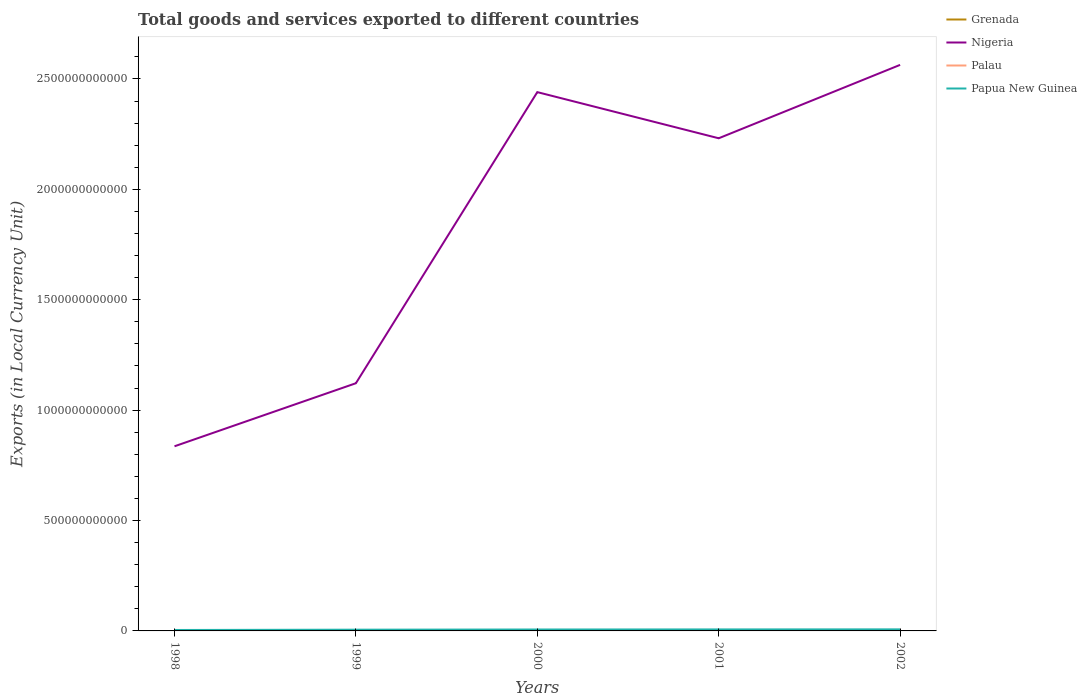Across all years, what is the maximum Amount of goods and services exports in Nigeria?
Provide a short and direct response. 8.36e+11. What is the total Amount of goods and services exports in Nigeria in the graph?
Offer a terse response. -1.40e+12. What is the difference between the highest and the second highest Amount of goods and services exports in Nigeria?
Offer a terse response. 1.73e+12. What is the difference between the highest and the lowest Amount of goods and services exports in Grenada?
Ensure brevity in your answer.  3. Is the Amount of goods and services exports in Nigeria strictly greater than the Amount of goods and services exports in Grenada over the years?
Keep it short and to the point. No. How many lines are there?
Offer a terse response. 4. How many years are there in the graph?
Your answer should be very brief. 5. What is the difference between two consecutive major ticks on the Y-axis?
Offer a terse response. 5.00e+11. Are the values on the major ticks of Y-axis written in scientific E-notation?
Keep it short and to the point. No. Does the graph contain grids?
Ensure brevity in your answer.  No. Where does the legend appear in the graph?
Offer a terse response. Top right. How many legend labels are there?
Offer a very short reply. 4. What is the title of the graph?
Your answer should be very brief. Total goods and services exported to different countries. Does "China" appear as one of the legend labels in the graph?
Ensure brevity in your answer.  No. What is the label or title of the X-axis?
Your response must be concise. Years. What is the label or title of the Y-axis?
Keep it short and to the point. Exports (in Local Currency Unit). What is the Exports (in Local Currency Unit) in Grenada in 1998?
Ensure brevity in your answer.  4.25e+08. What is the Exports (in Local Currency Unit) in Nigeria in 1998?
Offer a terse response. 8.36e+11. What is the Exports (in Local Currency Unit) of Palau in 1998?
Ensure brevity in your answer.  1.11e+07. What is the Exports (in Local Currency Unit) in Papua New Guinea in 1998?
Ensure brevity in your answer.  4.22e+09. What is the Exports (in Local Currency Unit) in Grenada in 1999?
Provide a short and direct response. 5.89e+08. What is the Exports (in Local Currency Unit) of Nigeria in 1999?
Your answer should be very brief. 1.12e+12. What is the Exports (in Local Currency Unit) of Palau in 1999?
Offer a very short reply. 1.36e+07. What is the Exports (in Local Currency Unit) of Papua New Guinea in 1999?
Provide a short and direct response. 5.57e+09. What is the Exports (in Local Currency Unit) in Grenada in 2000?
Give a very brief answer. 6.36e+08. What is the Exports (in Local Currency Unit) of Nigeria in 2000?
Your response must be concise. 2.44e+12. What is the Exports (in Local Currency Unit) in Palau in 2000?
Give a very brief answer. 6.67e+07. What is the Exports (in Local Currency Unit) in Papua New Guinea in 2000?
Your answer should be compact. 6.44e+09. What is the Exports (in Local Currency Unit) in Grenada in 2001?
Offer a terse response. 5.32e+08. What is the Exports (in Local Currency Unit) of Nigeria in 2001?
Your response must be concise. 2.23e+12. What is the Exports (in Local Currency Unit) of Palau in 2001?
Keep it short and to the point. 6.93e+07. What is the Exports (in Local Currency Unit) of Papua New Guinea in 2001?
Your answer should be compact. 6.79e+09. What is the Exports (in Local Currency Unit) of Grenada in 2002?
Provide a succinct answer. 4.66e+08. What is the Exports (in Local Currency Unit) in Nigeria in 2002?
Provide a succinct answer. 2.56e+12. What is the Exports (in Local Currency Unit) in Palau in 2002?
Make the answer very short. 7.42e+07. What is the Exports (in Local Currency Unit) in Papua New Guinea in 2002?
Give a very brief answer. 7.10e+09. Across all years, what is the maximum Exports (in Local Currency Unit) of Grenada?
Provide a short and direct response. 6.36e+08. Across all years, what is the maximum Exports (in Local Currency Unit) in Nigeria?
Keep it short and to the point. 2.56e+12. Across all years, what is the maximum Exports (in Local Currency Unit) of Palau?
Offer a terse response. 7.42e+07. Across all years, what is the maximum Exports (in Local Currency Unit) of Papua New Guinea?
Your response must be concise. 7.10e+09. Across all years, what is the minimum Exports (in Local Currency Unit) in Grenada?
Your answer should be very brief. 4.25e+08. Across all years, what is the minimum Exports (in Local Currency Unit) of Nigeria?
Offer a very short reply. 8.36e+11. Across all years, what is the minimum Exports (in Local Currency Unit) in Palau?
Your answer should be compact. 1.11e+07. Across all years, what is the minimum Exports (in Local Currency Unit) of Papua New Guinea?
Provide a succinct answer. 4.22e+09. What is the total Exports (in Local Currency Unit) of Grenada in the graph?
Offer a very short reply. 2.65e+09. What is the total Exports (in Local Currency Unit) of Nigeria in the graph?
Offer a terse response. 9.19e+12. What is the total Exports (in Local Currency Unit) of Palau in the graph?
Provide a short and direct response. 2.35e+08. What is the total Exports (in Local Currency Unit) in Papua New Guinea in the graph?
Your answer should be compact. 3.01e+1. What is the difference between the Exports (in Local Currency Unit) in Grenada in 1998 and that in 1999?
Ensure brevity in your answer.  -1.64e+08. What is the difference between the Exports (in Local Currency Unit) in Nigeria in 1998 and that in 1999?
Give a very brief answer. -2.86e+11. What is the difference between the Exports (in Local Currency Unit) of Palau in 1998 and that in 1999?
Give a very brief answer. -2.48e+06. What is the difference between the Exports (in Local Currency Unit) in Papua New Guinea in 1998 and that in 1999?
Keep it short and to the point. -1.36e+09. What is the difference between the Exports (in Local Currency Unit) of Grenada in 1998 and that in 2000?
Your response must be concise. -2.11e+08. What is the difference between the Exports (in Local Currency Unit) in Nigeria in 1998 and that in 2000?
Offer a terse response. -1.60e+12. What is the difference between the Exports (in Local Currency Unit) of Palau in 1998 and that in 2000?
Offer a terse response. -5.56e+07. What is the difference between the Exports (in Local Currency Unit) in Papua New Guinea in 1998 and that in 2000?
Your answer should be compact. -2.23e+09. What is the difference between the Exports (in Local Currency Unit) in Grenada in 1998 and that in 2001?
Your answer should be very brief. -1.07e+08. What is the difference between the Exports (in Local Currency Unit) in Nigeria in 1998 and that in 2001?
Your answer should be compact. -1.40e+12. What is the difference between the Exports (in Local Currency Unit) in Palau in 1998 and that in 2001?
Your response must be concise. -5.82e+07. What is the difference between the Exports (in Local Currency Unit) of Papua New Guinea in 1998 and that in 2001?
Offer a terse response. -2.57e+09. What is the difference between the Exports (in Local Currency Unit) of Grenada in 1998 and that in 2002?
Ensure brevity in your answer.  -4.11e+07. What is the difference between the Exports (in Local Currency Unit) in Nigeria in 1998 and that in 2002?
Offer a very short reply. -1.73e+12. What is the difference between the Exports (in Local Currency Unit) in Palau in 1998 and that in 2002?
Provide a succinct answer. -6.31e+07. What is the difference between the Exports (in Local Currency Unit) in Papua New Guinea in 1998 and that in 2002?
Ensure brevity in your answer.  -2.88e+09. What is the difference between the Exports (in Local Currency Unit) in Grenada in 1999 and that in 2000?
Provide a short and direct response. -4.78e+07. What is the difference between the Exports (in Local Currency Unit) of Nigeria in 1999 and that in 2000?
Provide a succinct answer. -1.32e+12. What is the difference between the Exports (in Local Currency Unit) of Palau in 1999 and that in 2000?
Provide a succinct answer. -5.31e+07. What is the difference between the Exports (in Local Currency Unit) of Papua New Guinea in 1999 and that in 2000?
Your answer should be compact. -8.71e+08. What is the difference between the Exports (in Local Currency Unit) in Grenada in 1999 and that in 2001?
Offer a terse response. 5.64e+07. What is the difference between the Exports (in Local Currency Unit) of Nigeria in 1999 and that in 2001?
Offer a very short reply. -1.11e+12. What is the difference between the Exports (in Local Currency Unit) of Palau in 1999 and that in 2001?
Make the answer very short. -5.57e+07. What is the difference between the Exports (in Local Currency Unit) in Papua New Guinea in 1999 and that in 2001?
Your answer should be very brief. -1.22e+09. What is the difference between the Exports (in Local Currency Unit) in Grenada in 1999 and that in 2002?
Your answer should be compact. 1.23e+08. What is the difference between the Exports (in Local Currency Unit) of Nigeria in 1999 and that in 2002?
Offer a terse response. -1.44e+12. What is the difference between the Exports (in Local Currency Unit) in Palau in 1999 and that in 2002?
Your response must be concise. -6.07e+07. What is the difference between the Exports (in Local Currency Unit) of Papua New Guinea in 1999 and that in 2002?
Make the answer very short. -1.53e+09. What is the difference between the Exports (in Local Currency Unit) of Grenada in 2000 and that in 2001?
Ensure brevity in your answer.  1.04e+08. What is the difference between the Exports (in Local Currency Unit) of Nigeria in 2000 and that in 2001?
Ensure brevity in your answer.  2.09e+11. What is the difference between the Exports (in Local Currency Unit) of Palau in 2000 and that in 2001?
Offer a very short reply. -2.56e+06. What is the difference between the Exports (in Local Currency Unit) of Papua New Guinea in 2000 and that in 2001?
Give a very brief answer. -3.49e+08. What is the difference between the Exports (in Local Currency Unit) in Grenada in 2000 and that in 2002?
Offer a very short reply. 1.70e+08. What is the difference between the Exports (in Local Currency Unit) in Nigeria in 2000 and that in 2002?
Your answer should be compact. -1.23e+11. What is the difference between the Exports (in Local Currency Unit) in Palau in 2000 and that in 2002?
Give a very brief answer. -7.53e+06. What is the difference between the Exports (in Local Currency Unit) of Papua New Guinea in 2000 and that in 2002?
Provide a succinct answer. -6.57e+08. What is the difference between the Exports (in Local Currency Unit) in Grenada in 2001 and that in 2002?
Provide a short and direct response. 6.62e+07. What is the difference between the Exports (in Local Currency Unit) in Nigeria in 2001 and that in 2002?
Your response must be concise. -3.32e+11. What is the difference between the Exports (in Local Currency Unit) of Palau in 2001 and that in 2002?
Provide a succinct answer. -4.97e+06. What is the difference between the Exports (in Local Currency Unit) in Papua New Guinea in 2001 and that in 2002?
Offer a very short reply. -3.08e+08. What is the difference between the Exports (in Local Currency Unit) in Grenada in 1998 and the Exports (in Local Currency Unit) in Nigeria in 1999?
Make the answer very short. -1.12e+12. What is the difference between the Exports (in Local Currency Unit) of Grenada in 1998 and the Exports (in Local Currency Unit) of Palau in 1999?
Provide a succinct answer. 4.11e+08. What is the difference between the Exports (in Local Currency Unit) in Grenada in 1998 and the Exports (in Local Currency Unit) in Papua New Guinea in 1999?
Give a very brief answer. -5.15e+09. What is the difference between the Exports (in Local Currency Unit) in Nigeria in 1998 and the Exports (in Local Currency Unit) in Palau in 1999?
Your answer should be compact. 8.36e+11. What is the difference between the Exports (in Local Currency Unit) in Nigeria in 1998 and the Exports (in Local Currency Unit) in Papua New Guinea in 1999?
Provide a short and direct response. 8.31e+11. What is the difference between the Exports (in Local Currency Unit) in Palau in 1998 and the Exports (in Local Currency Unit) in Papua New Guinea in 1999?
Your answer should be very brief. -5.56e+09. What is the difference between the Exports (in Local Currency Unit) of Grenada in 1998 and the Exports (in Local Currency Unit) of Nigeria in 2000?
Your answer should be compact. -2.44e+12. What is the difference between the Exports (in Local Currency Unit) in Grenada in 1998 and the Exports (in Local Currency Unit) in Palau in 2000?
Your answer should be compact. 3.58e+08. What is the difference between the Exports (in Local Currency Unit) of Grenada in 1998 and the Exports (in Local Currency Unit) of Papua New Guinea in 2000?
Offer a very short reply. -6.02e+09. What is the difference between the Exports (in Local Currency Unit) in Nigeria in 1998 and the Exports (in Local Currency Unit) in Palau in 2000?
Give a very brief answer. 8.36e+11. What is the difference between the Exports (in Local Currency Unit) of Nigeria in 1998 and the Exports (in Local Currency Unit) of Papua New Guinea in 2000?
Give a very brief answer. 8.30e+11. What is the difference between the Exports (in Local Currency Unit) of Palau in 1998 and the Exports (in Local Currency Unit) of Papua New Guinea in 2000?
Keep it short and to the point. -6.43e+09. What is the difference between the Exports (in Local Currency Unit) in Grenada in 1998 and the Exports (in Local Currency Unit) in Nigeria in 2001?
Offer a terse response. -2.23e+12. What is the difference between the Exports (in Local Currency Unit) of Grenada in 1998 and the Exports (in Local Currency Unit) of Palau in 2001?
Ensure brevity in your answer.  3.56e+08. What is the difference between the Exports (in Local Currency Unit) in Grenada in 1998 and the Exports (in Local Currency Unit) in Papua New Guinea in 2001?
Your answer should be compact. -6.37e+09. What is the difference between the Exports (in Local Currency Unit) in Nigeria in 1998 and the Exports (in Local Currency Unit) in Palau in 2001?
Give a very brief answer. 8.36e+11. What is the difference between the Exports (in Local Currency Unit) in Nigeria in 1998 and the Exports (in Local Currency Unit) in Papua New Guinea in 2001?
Give a very brief answer. 8.29e+11. What is the difference between the Exports (in Local Currency Unit) in Palau in 1998 and the Exports (in Local Currency Unit) in Papua New Guinea in 2001?
Your answer should be compact. -6.78e+09. What is the difference between the Exports (in Local Currency Unit) in Grenada in 1998 and the Exports (in Local Currency Unit) in Nigeria in 2002?
Your answer should be very brief. -2.56e+12. What is the difference between the Exports (in Local Currency Unit) in Grenada in 1998 and the Exports (in Local Currency Unit) in Palau in 2002?
Give a very brief answer. 3.51e+08. What is the difference between the Exports (in Local Currency Unit) in Grenada in 1998 and the Exports (in Local Currency Unit) in Papua New Guinea in 2002?
Ensure brevity in your answer.  -6.68e+09. What is the difference between the Exports (in Local Currency Unit) in Nigeria in 1998 and the Exports (in Local Currency Unit) in Palau in 2002?
Your answer should be compact. 8.36e+11. What is the difference between the Exports (in Local Currency Unit) in Nigeria in 1998 and the Exports (in Local Currency Unit) in Papua New Guinea in 2002?
Offer a terse response. 8.29e+11. What is the difference between the Exports (in Local Currency Unit) in Palau in 1998 and the Exports (in Local Currency Unit) in Papua New Guinea in 2002?
Make the answer very short. -7.09e+09. What is the difference between the Exports (in Local Currency Unit) of Grenada in 1999 and the Exports (in Local Currency Unit) of Nigeria in 2000?
Make the answer very short. -2.44e+12. What is the difference between the Exports (in Local Currency Unit) in Grenada in 1999 and the Exports (in Local Currency Unit) in Palau in 2000?
Provide a succinct answer. 5.22e+08. What is the difference between the Exports (in Local Currency Unit) of Grenada in 1999 and the Exports (in Local Currency Unit) of Papua New Guinea in 2000?
Offer a terse response. -5.85e+09. What is the difference between the Exports (in Local Currency Unit) of Nigeria in 1999 and the Exports (in Local Currency Unit) of Palau in 2000?
Your answer should be very brief. 1.12e+12. What is the difference between the Exports (in Local Currency Unit) of Nigeria in 1999 and the Exports (in Local Currency Unit) of Papua New Guinea in 2000?
Your answer should be very brief. 1.12e+12. What is the difference between the Exports (in Local Currency Unit) in Palau in 1999 and the Exports (in Local Currency Unit) in Papua New Guinea in 2000?
Provide a succinct answer. -6.43e+09. What is the difference between the Exports (in Local Currency Unit) in Grenada in 1999 and the Exports (in Local Currency Unit) in Nigeria in 2001?
Give a very brief answer. -2.23e+12. What is the difference between the Exports (in Local Currency Unit) in Grenada in 1999 and the Exports (in Local Currency Unit) in Palau in 2001?
Give a very brief answer. 5.19e+08. What is the difference between the Exports (in Local Currency Unit) of Grenada in 1999 and the Exports (in Local Currency Unit) of Papua New Guinea in 2001?
Your answer should be very brief. -6.20e+09. What is the difference between the Exports (in Local Currency Unit) in Nigeria in 1999 and the Exports (in Local Currency Unit) in Palau in 2001?
Provide a short and direct response. 1.12e+12. What is the difference between the Exports (in Local Currency Unit) of Nigeria in 1999 and the Exports (in Local Currency Unit) of Papua New Guinea in 2001?
Make the answer very short. 1.12e+12. What is the difference between the Exports (in Local Currency Unit) of Palau in 1999 and the Exports (in Local Currency Unit) of Papua New Guinea in 2001?
Provide a succinct answer. -6.78e+09. What is the difference between the Exports (in Local Currency Unit) of Grenada in 1999 and the Exports (in Local Currency Unit) of Nigeria in 2002?
Keep it short and to the point. -2.56e+12. What is the difference between the Exports (in Local Currency Unit) in Grenada in 1999 and the Exports (in Local Currency Unit) in Palau in 2002?
Your response must be concise. 5.14e+08. What is the difference between the Exports (in Local Currency Unit) of Grenada in 1999 and the Exports (in Local Currency Unit) of Papua New Guinea in 2002?
Offer a very short reply. -6.51e+09. What is the difference between the Exports (in Local Currency Unit) of Nigeria in 1999 and the Exports (in Local Currency Unit) of Palau in 2002?
Provide a succinct answer. 1.12e+12. What is the difference between the Exports (in Local Currency Unit) in Nigeria in 1999 and the Exports (in Local Currency Unit) in Papua New Guinea in 2002?
Provide a short and direct response. 1.11e+12. What is the difference between the Exports (in Local Currency Unit) in Palau in 1999 and the Exports (in Local Currency Unit) in Papua New Guinea in 2002?
Ensure brevity in your answer.  -7.09e+09. What is the difference between the Exports (in Local Currency Unit) of Grenada in 2000 and the Exports (in Local Currency Unit) of Nigeria in 2001?
Provide a succinct answer. -2.23e+12. What is the difference between the Exports (in Local Currency Unit) in Grenada in 2000 and the Exports (in Local Currency Unit) in Palau in 2001?
Your answer should be very brief. 5.67e+08. What is the difference between the Exports (in Local Currency Unit) of Grenada in 2000 and the Exports (in Local Currency Unit) of Papua New Guinea in 2001?
Provide a succinct answer. -6.16e+09. What is the difference between the Exports (in Local Currency Unit) of Nigeria in 2000 and the Exports (in Local Currency Unit) of Palau in 2001?
Offer a very short reply. 2.44e+12. What is the difference between the Exports (in Local Currency Unit) in Nigeria in 2000 and the Exports (in Local Currency Unit) in Papua New Guinea in 2001?
Provide a short and direct response. 2.43e+12. What is the difference between the Exports (in Local Currency Unit) in Palau in 2000 and the Exports (in Local Currency Unit) in Papua New Guinea in 2001?
Offer a very short reply. -6.73e+09. What is the difference between the Exports (in Local Currency Unit) of Grenada in 2000 and the Exports (in Local Currency Unit) of Nigeria in 2002?
Offer a terse response. -2.56e+12. What is the difference between the Exports (in Local Currency Unit) in Grenada in 2000 and the Exports (in Local Currency Unit) in Palau in 2002?
Your answer should be compact. 5.62e+08. What is the difference between the Exports (in Local Currency Unit) in Grenada in 2000 and the Exports (in Local Currency Unit) in Papua New Guinea in 2002?
Offer a very short reply. -6.46e+09. What is the difference between the Exports (in Local Currency Unit) of Nigeria in 2000 and the Exports (in Local Currency Unit) of Palau in 2002?
Provide a succinct answer. 2.44e+12. What is the difference between the Exports (in Local Currency Unit) of Nigeria in 2000 and the Exports (in Local Currency Unit) of Papua New Guinea in 2002?
Give a very brief answer. 2.43e+12. What is the difference between the Exports (in Local Currency Unit) of Palau in 2000 and the Exports (in Local Currency Unit) of Papua New Guinea in 2002?
Your response must be concise. -7.03e+09. What is the difference between the Exports (in Local Currency Unit) in Grenada in 2001 and the Exports (in Local Currency Unit) in Nigeria in 2002?
Keep it short and to the point. -2.56e+12. What is the difference between the Exports (in Local Currency Unit) of Grenada in 2001 and the Exports (in Local Currency Unit) of Palau in 2002?
Provide a succinct answer. 4.58e+08. What is the difference between the Exports (in Local Currency Unit) of Grenada in 2001 and the Exports (in Local Currency Unit) of Papua New Guinea in 2002?
Offer a very short reply. -6.57e+09. What is the difference between the Exports (in Local Currency Unit) in Nigeria in 2001 and the Exports (in Local Currency Unit) in Palau in 2002?
Offer a very short reply. 2.23e+12. What is the difference between the Exports (in Local Currency Unit) in Nigeria in 2001 and the Exports (in Local Currency Unit) in Papua New Guinea in 2002?
Make the answer very short. 2.22e+12. What is the difference between the Exports (in Local Currency Unit) in Palau in 2001 and the Exports (in Local Currency Unit) in Papua New Guinea in 2002?
Make the answer very short. -7.03e+09. What is the average Exports (in Local Currency Unit) in Grenada per year?
Keep it short and to the point. 5.30e+08. What is the average Exports (in Local Currency Unit) of Nigeria per year?
Give a very brief answer. 1.84e+12. What is the average Exports (in Local Currency Unit) of Palau per year?
Keep it short and to the point. 4.70e+07. What is the average Exports (in Local Currency Unit) of Papua New Guinea per year?
Provide a succinct answer. 6.02e+09. In the year 1998, what is the difference between the Exports (in Local Currency Unit) of Grenada and Exports (in Local Currency Unit) of Nigeria?
Keep it short and to the point. -8.36e+11. In the year 1998, what is the difference between the Exports (in Local Currency Unit) in Grenada and Exports (in Local Currency Unit) in Palau?
Provide a succinct answer. 4.14e+08. In the year 1998, what is the difference between the Exports (in Local Currency Unit) of Grenada and Exports (in Local Currency Unit) of Papua New Guinea?
Provide a succinct answer. -3.79e+09. In the year 1998, what is the difference between the Exports (in Local Currency Unit) of Nigeria and Exports (in Local Currency Unit) of Palau?
Provide a succinct answer. 8.36e+11. In the year 1998, what is the difference between the Exports (in Local Currency Unit) of Nigeria and Exports (in Local Currency Unit) of Papua New Guinea?
Provide a succinct answer. 8.32e+11. In the year 1998, what is the difference between the Exports (in Local Currency Unit) of Palau and Exports (in Local Currency Unit) of Papua New Guinea?
Offer a very short reply. -4.21e+09. In the year 1999, what is the difference between the Exports (in Local Currency Unit) in Grenada and Exports (in Local Currency Unit) in Nigeria?
Make the answer very short. -1.12e+12. In the year 1999, what is the difference between the Exports (in Local Currency Unit) in Grenada and Exports (in Local Currency Unit) in Palau?
Keep it short and to the point. 5.75e+08. In the year 1999, what is the difference between the Exports (in Local Currency Unit) in Grenada and Exports (in Local Currency Unit) in Papua New Guinea?
Give a very brief answer. -4.98e+09. In the year 1999, what is the difference between the Exports (in Local Currency Unit) of Nigeria and Exports (in Local Currency Unit) of Palau?
Offer a terse response. 1.12e+12. In the year 1999, what is the difference between the Exports (in Local Currency Unit) of Nigeria and Exports (in Local Currency Unit) of Papua New Guinea?
Keep it short and to the point. 1.12e+12. In the year 1999, what is the difference between the Exports (in Local Currency Unit) of Palau and Exports (in Local Currency Unit) of Papua New Guinea?
Keep it short and to the point. -5.56e+09. In the year 2000, what is the difference between the Exports (in Local Currency Unit) in Grenada and Exports (in Local Currency Unit) in Nigeria?
Give a very brief answer. -2.44e+12. In the year 2000, what is the difference between the Exports (in Local Currency Unit) in Grenada and Exports (in Local Currency Unit) in Palau?
Offer a terse response. 5.70e+08. In the year 2000, what is the difference between the Exports (in Local Currency Unit) of Grenada and Exports (in Local Currency Unit) of Papua New Guinea?
Make the answer very short. -5.81e+09. In the year 2000, what is the difference between the Exports (in Local Currency Unit) in Nigeria and Exports (in Local Currency Unit) in Palau?
Ensure brevity in your answer.  2.44e+12. In the year 2000, what is the difference between the Exports (in Local Currency Unit) in Nigeria and Exports (in Local Currency Unit) in Papua New Guinea?
Keep it short and to the point. 2.43e+12. In the year 2000, what is the difference between the Exports (in Local Currency Unit) of Palau and Exports (in Local Currency Unit) of Papua New Guinea?
Provide a succinct answer. -6.38e+09. In the year 2001, what is the difference between the Exports (in Local Currency Unit) in Grenada and Exports (in Local Currency Unit) in Nigeria?
Make the answer very short. -2.23e+12. In the year 2001, what is the difference between the Exports (in Local Currency Unit) in Grenada and Exports (in Local Currency Unit) in Palau?
Offer a very short reply. 4.63e+08. In the year 2001, what is the difference between the Exports (in Local Currency Unit) in Grenada and Exports (in Local Currency Unit) in Papua New Guinea?
Provide a short and direct response. -6.26e+09. In the year 2001, what is the difference between the Exports (in Local Currency Unit) in Nigeria and Exports (in Local Currency Unit) in Palau?
Your answer should be compact. 2.23e+12. In the year 2001, what is the difference between the Exports (in Local Currency Unit) in Nigeria and Exports (in Local Currency Unit) in Papua New Guinea?
Give a very brief answer. 2.22e+12. In the year 2001, what is the difference between the Exports (in Local Currency Unit) in Palau and Exports (in Local Currency Unit) in Papua New Guinea?
Provide a succinct answer. -6.72e+09. In the year 2002, what is the difference between the Exports (in Local Currency Unit) in Grenada and Exports (in Local Currency Unit) in Nigeria?
Provide a succinct answer. -2.56e+12. In the year 2002, what is the difference between the Exports (in Local Currency Unit) in Grenada and Exports (in Local Currency Unit) in Palau?
Offer a very short reply. 3.92e+08. In the year 2002, what is the difference between the Exports (in Local Currency Unit) in Grenada and Exports (in Local Currency Unit) in Papua New Guinea?
Provide a short and direct response. -6.63e+09. In the year 2002, what is the difference between the Exports (in Local Currency Unit) in Nigeria and Exports (in Local Currency Unit) in Palau?
Provide a short and direct response. 2.56e+12. In the year 2002, what is the difference between the Exports (in Local Currency Unit) in Nigeria and Exports (in Local Currency Unit) in Papua New Guinea?
Your response must be concise. 2.56e+12. In the year 2002, what is the difference between the Exports (in Local Currency Unit) in Palau and Exports (in Local Currency Unit) in Papua New Guinea?
Your response must be concise. -7.03e+09. What is the ratio of the Exports (in Local Currency Unit) in Grenada in 1998 to that in 1999?
Offer a terse response. 0.72. What is the ratio of the Exports (in Local Currency Unit) of Nigeria in 1998 to that in 1999?
Provide a short and direct response. 0.75. What is the ratio of the Exports (in Local Currency Unit) in Palau in 1998 to that in 1999?
Provide a succinct answer. 0.82. What is the ratio of the Exports (in Local Currency Unit) of Papua New Guinea in 1998 to that in 1999?
Give a very brief answer. 0.76. What is the ratio of the Exports (in Local Currency Unit) in Grenada in 1998 to that in 2000?
Provide a short and direct response. 0.67. What is the ratio of the Exports (in Local Currency Unit) of Nigeria in 1998 to that in 2000?
Provide a short and direct response. 0.34. What is the ratio of the Exports (in Local Currency Unit) in Palau in 1998 to that in 2000?
Your answer should be very brief. 0.17. What is the ratio of the Exports (in Local Currency Unit) of Papua New Guinea in 1998 to that in 2000?
Provide a succinct answer. 0.65. What is the ratio of the Exports (in Local Currency Unit) of Grenada in 1998 to that in 2001?
Provide a short and direct response. 0.8. What is the ratio of the Exports (in Local Currency Unit) of Nigeria in 1998 to that in 2001?
Your response must be concise. 0.37. What is the ratio of the Exports (in Local Currency Unit) of Palau in 1998 to that in 2001?
Make the answer very short. 0.16. What is the ratio of the Exports (in Local Currency Unit) of Papua New Guinea in 1998 to that in 2001?
Offer a terse response. 0.62. What is the ratio of the Exports (in Local Currency Unit) in Grenada in 1998 to that in 2002?
Keep it short and to the point. 0.91. What is the ratio of the Exports (in Local Currency Unit) in Nigeria in 1998 to that in 2002?
Your response must be concise. 0.33. What is the ratio of the Exports (in Local Currency Unit) of Palau in 1998 to that in 2002?
Make the answer very short. 0.15. What is the ratio of the Exports (in Local Currency Unit) of Papua New Guinea in 1998 to that in 2002?
Your response must be concise. 0.59. What is the ratio of the Exports (in Local Currency Unit) in Grenada in 1999 to that in 2000?
Offer a terse response. 0.93. What is the ratio of the Exports (in Local Currency Unit) in Nigeria in 1999 to that in 2000?
Ensure brevity in your answer.  0.46. What is the ratio of the Exports (in Local Currency Unit) in Palau in 1999 to that in 2000?
Your answer should be compact. 0.2. What is the ratio of the Exports (in Local Currency Unit) of Papua New Guinea in 1999 to that in 2000?
Keep it short and to the point. 0.86. What is the ratio of the Exports (in Local Currency Unit) in Grenada in 1999 to that in 2001?
Keep it short and to the point. 1.11. What is the ratio of the Exports (in Local Currency Unit) in Nigeria in 1999 to that in 2001?
Your answer should be compact. 0.5. What is the ratio of the Exports (in Local Currency Unit) in Palau in 1999 to that in 2001?
Offer a terse response. 0.2. What is the ratio of the Exports (in Local Currency Unit) in Papua New Guinea in 1999 to that in 2001?
Provide a short and direct response. 0.82. What is the ratio of the Exports (in Local Currency Unit) of Grenada in 1999 to that in 2002?
Offer a very short reply. 1.26. What is the ratio of the Exports (in Local Currency Unit) in Nigeria in 1999 to that in 2002?
Your answer should be very brief. 0.44. What is the ratio of the Exports (in Local Currency Unit) of Palau in 1999 to that in 2002?
Your answer should be compact. 0.18. What is the ratio of the Exports (in Local Currency Unit) in Papua New Guinea in 1999 to that in 2002?
Your answer should be compact. 0.78. What is the ratio of the Exports (in Local Currency Unit) in Grenada in 2000 to that in 2001?
Offer a terse response. 1.2. What is the ratio of the Exports (in Local Currency Unit) in Nigeria in 2000 to that in 2001?
Your answer should be compact. 1.09. What is the ratio of the Exports (in Local Currency Unit) of Palau in 2000 to that in 2001?
Give a very brief answer. 0.96. What is the ratio of the Exports (in Local Currency Unit) of Papua New Guinea in 2000 to that in 2001?
Provide a short and direct response. 0.95. What is the ratio of the Exports (in Local Currency Unit) in Grenada in 2000 to that in 2002?
Provide a succinct answer. 1.37. What is the ratio of the Exports (in Local Currency Unit) in Nigeria in 2000 to that in 2002?
Your answer should be compact. 0.95. What is the ratio of the Exports (in Local Currency Unit) in Palau in 2000 to that in 2002?
Offer a terse response. 0.9. What is the ratio of the Exports (in Local Currency Unit) of Papua New Guinea in 2000 to that in 2002?
Ensure brevity in your answer.  0.91. What is the ratio of the Exports (in Local Currency Unit) of Grenada in 2001 to that in 2002?
Your answer should be very brief. 1.14. What is the ratio of the Exports (in Local Currency Unit) of Nigeria in 2001 to that in 2002?
Your response must be concise. 0.87. What is the ratio of the Exports (in Local Currency Unit) in Palau in 2001 to that in 2002?
Offer a terse response. 0.93. What is the ratio of the Exports (in Local Currency Unit) of Papua New Guinea in 2001 to that in 2002?
Provide a succinct answer. 0.96. What is the difference between the highest and the second highest Exports (in Local Currency Unit) of Grenada?
Give a very brief answer. 4.78e+07. What is the difference between the highest and the second highest Exports (in Local Currency Unit) of Nigeria?
Give a very brief answer. 1.23e+11. What is the difference between the highest and the second highest Exports (in Local Currency Unit) in Palau?
Your answer should be very brief. 4.97e+06. What is the difference between the highest and the second highest Exports (in Local Currency Unit) of Papua New Guinea?
Ensure brevity in your answer.  3.08e+08. What is the difference between the highest and the lowest Exports (in Local Currency Unit) in Grenada?
Offer a terse response. 2.11e+08. What is the difference between the highest and the lowest Exports (in Local Currency Unit) of Nigeria?
Offer a terse response. 1.73e+12. What is the difference between the highest and the lowest Exports (in Local Currency Unit) of Palau?
Your answer should be very brief. 6.31e+07. What is the difference between the highest and the lowest Exports (in Local Currency Unit) of Papua New Guinea?
Keep it short and to the point. 2.88e+09. 